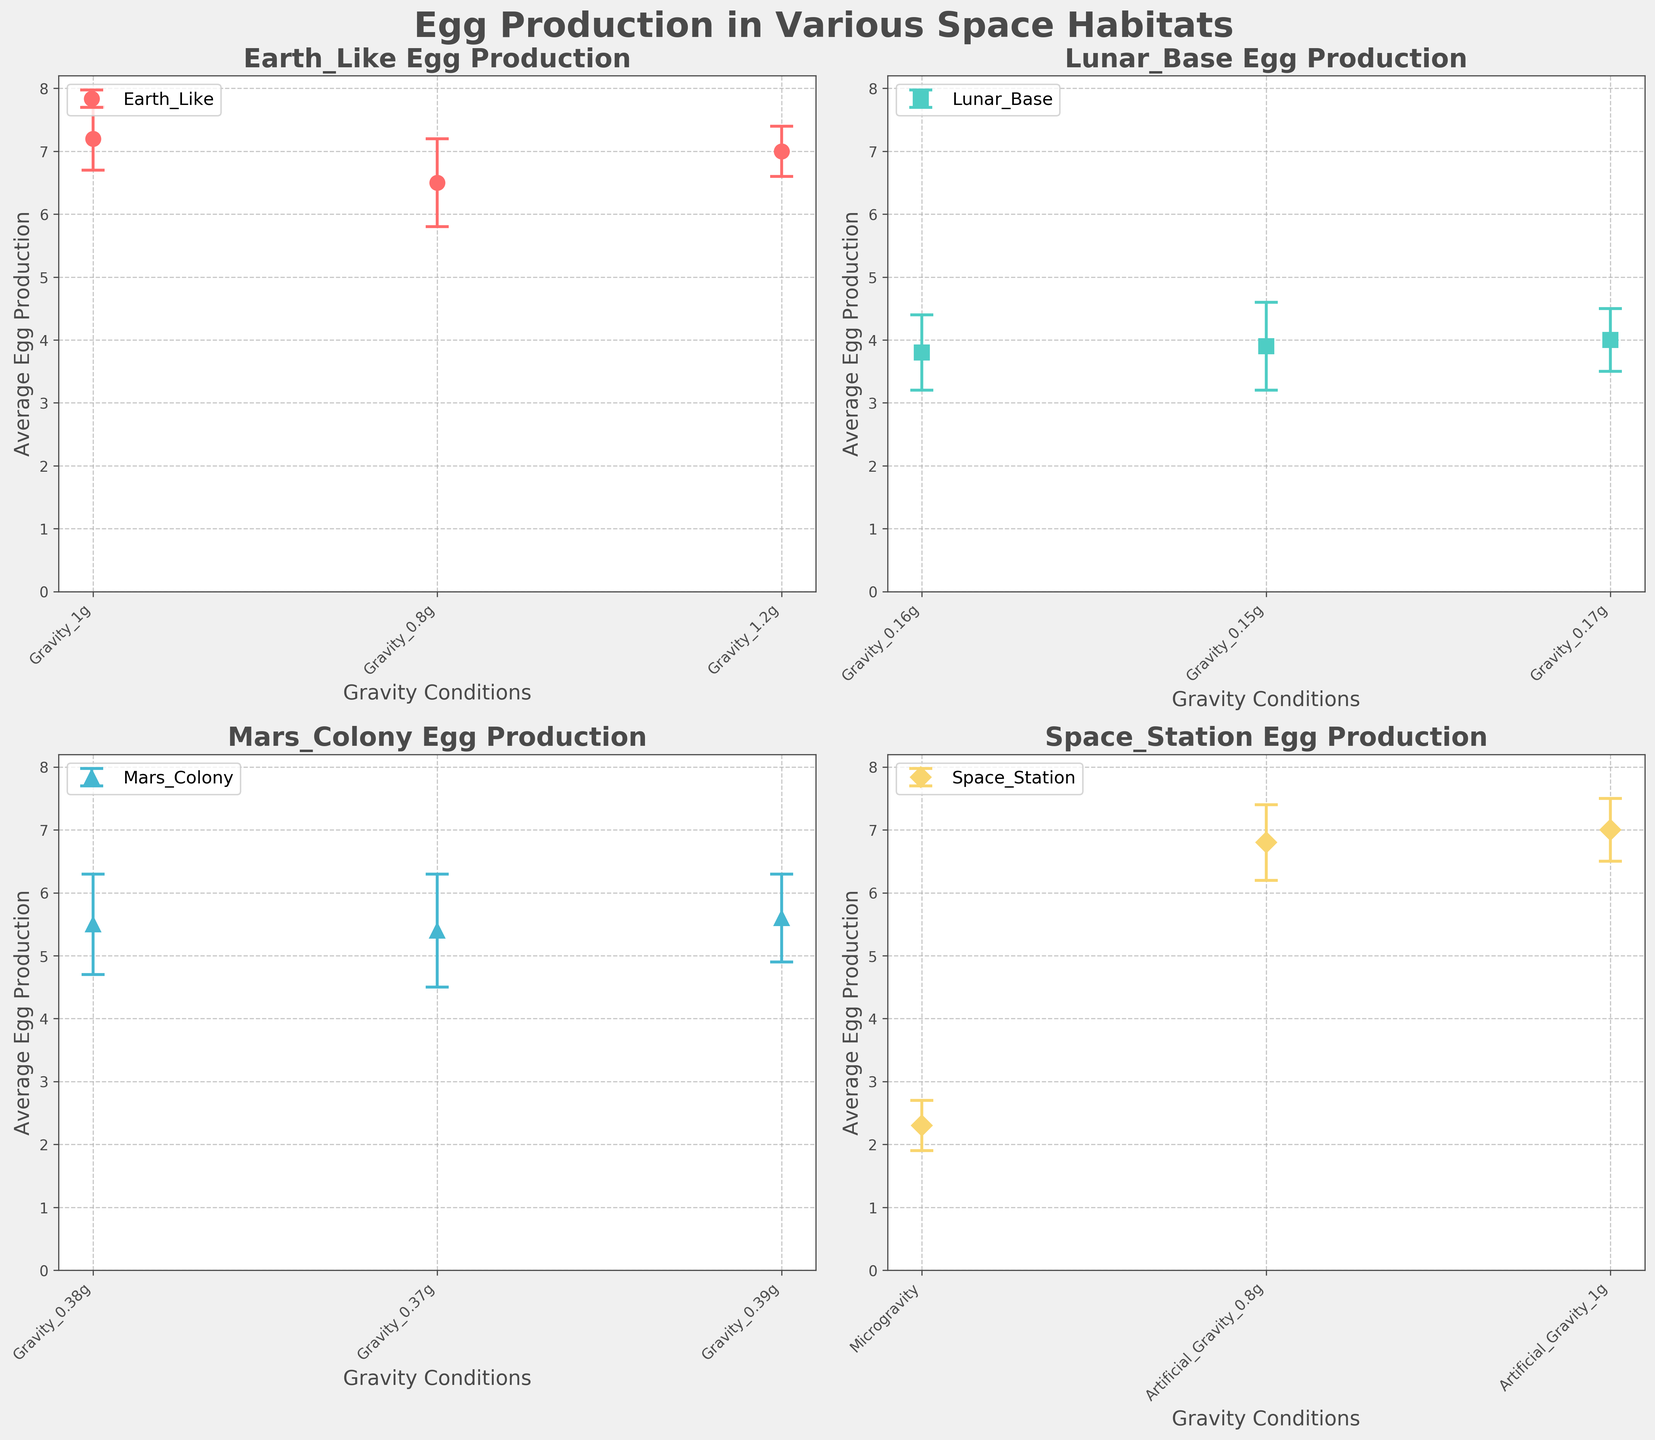What's the title of the figure? The title of the figure is displayed at the top, usually in a larger and bold font for emphasis.
Answer: Egg Production in Various Space Habitats What's the range of the y-axis in the subplots? By observing the y-axis labels in the subplots, it's clear that they range from 0 to a value slightly above the maximum average egg production. In this case, it goes from 0 to 8.
Answer: 0 to 8 Which habitat shows the lowest average egg production? By looking at the subplots and comparing the bar heights, the Space Station in microgravity conditions shows the lowest average egg production.
Answer: Space Station (Microgravity) What is the average egg production under Earth-like gravity conditions? The Earth_Like subplot shows three average egg production values: 7.2, 6.5, and 7.0. Summing these and dividing by the number of samples gives (7.2 + 6.5 + 7.0) / 3 = 6.9.
Answer: 6.9 How many data points are used for the Lunar Base subplot? Counting the number of points (one for each gravity condition) in the Lunar Base subplot reveals there are three data points.
Answer: 3 Which habitat has the most uniform egg production, considering the standard deviations? By comparing the error bars' lengths in each subplot, the Earth_Like habitat shows the smallest standard deviations, indicating the most uniform production.
Answer: Earth_Like What is the difference in average egg production between Mars_Colony and Space_Station with artificial gravity at 0.8g? The Mars_Colony has egg production values of 5.5, 5.4, and 5.6, with an average of (5.5 + 5.4 + 5.6)/3 = 5.5. Space_Station with artificial gravity of 0.8g has an egg production of 6.8. The difference is 6.8 - 5.5 = 1.3.
Answer: 1.3 Which habitat shows the largest variability in egg production? By observing the error bars in each subplot, the Mars_Colony habitat shows the largest variability with considerable standard deviations.
Answer: Mars_Colony Does the Space_Station with Microgravity have a higher or lower egg production than Mars_Colony with Gravity_0.38g? The Space_Station with microgravity shows an egg production of 2.3, while the Mars_Colony with Gravity_0.38g shows an egg production of 5.5. Thus, the Space_Station has a lower egg production.
Answer: Lower 